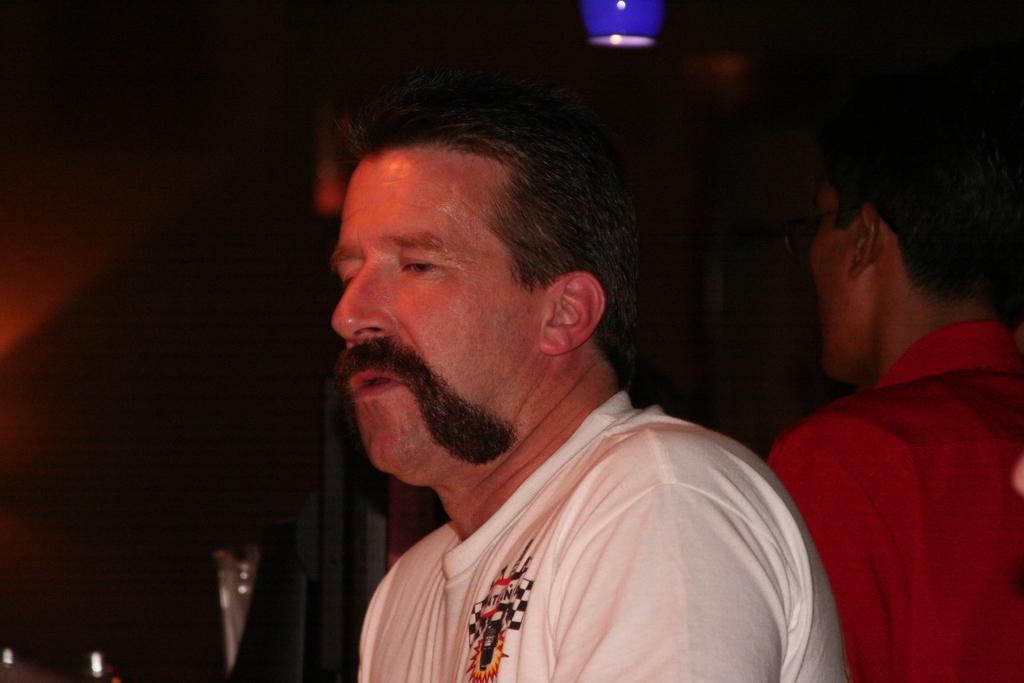Could you give a brief overview of what you see in this image? In this image we can see two men. On the backside we can see a ceiling lamp and a metal pole. 